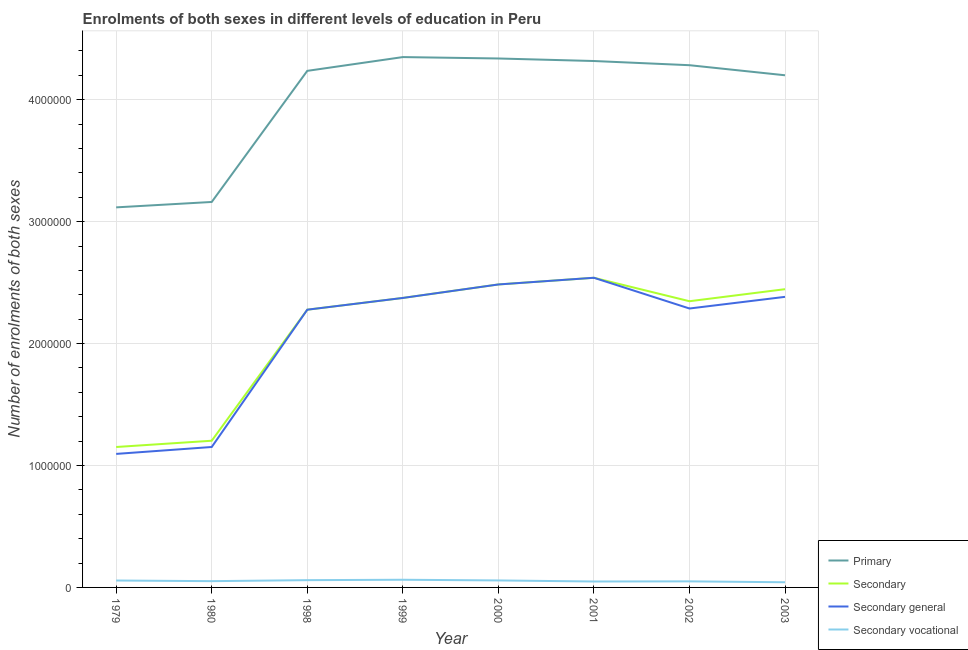How many different coloured lines are there?
Your answer should be compact. 4. Does the line corresponding to number of enrolments in secondary vocational education intersect with the line corresponding to number of enrolments in secondary education?
Your answer should be compact. No. What is the number of enrolments in secondary education in 2001?
Make the answer very short. 2.54e+06. Across all years, what is the maximum number of enrolments in secondary general education?
Provide a short and direct response. 2.54e+06. Across all years, what is the minimum number of enrolments in primary education?
Your response must be concise. 3.12e+06. In which year was the number of enrolments in secondary vocational education minimum?
Your response must be concise. 2003. What is the total number of enrolments in secondary vocational education in the graph?
Keep it short and to the point. 4.29e+05. What is the difference between the number of enrolments in secondary education in 2000 and that in 2002?
Make the answer very short. 1.38e+05. What is the difference between the number of enrolments in secondary vocational education in 2002 and the number of enrolments in secondary general education in 2001?
Offer a very short reply. -2.49e+06. What is the average number of enrolments in primary education per year?
Make the answer very short. 4.00e+06. In the year 2002, what is the difference between the number of enrolments in secondary education and number of enrolments in secondary vocational education?
Offer a very short reply. 2.30e+06. In how many years, is the number of enrolments in secondary general education greater than 4200000?
Provide a succinct answer. 0. What is the ratio of the number of enrolments in secondary general education in 2001 to that in 2002?
Offer a very short reply. 1.11. Is the number of enrolments in secondary general education in 1979 less than that in 1998?
Provide a succinct answer. Yes. What is the difference between the highest and the second highest number of enrolments in secondary education?
Provide a short and direct response. 5.49e+04. What is the difference between the highest and the lowest number of enrolments in secondary vocational education?
Ensure brevity in your answer.  2.05e+04. Does the number of enrolments in secondary education monotonically increase over the years?
Provide a succinct answer. No. Is the number of enrolments in secondary education strictly greater than the number of enrolments in secondary vocational education over the years?
Offer a terse response. Yes. Is the number of enrolments in secondary education strictly less than the number of enrolments in secondary general education over the years?
Make the answer very short. No. How many years are there in the graph?
Your answer should be very brief. 8. Does the graph contain grids?
Give a very brief answer. Yes. What is the title of the graph?
Offer a very short reply. Enrolments of both sexes in different levels of education in Peru. What is the label or title of the X-axis?
Provide a short and direct response. Year. What is the label or title of the Y-axis?
Your response must be concise. Number of enrolments of both sexes. What is the Number of enrolments of both sexes of Primary in 1979?
Provide a succinct answer. 3.12e+06. What is the Number of enrolments of both sexes in Secondary in 1979?
Make the answer very short. 1.15e+06. What is the Number of enrolments of both sexes in Secondary general in 1979?
Your answer should be compact. 1.10e+06. What is the Number of enrolments of both sexes in Secondary vocational in 1979?
Make the answer very short. 5.67e+04. What is the Number of enrolments of both sexes in Primary in 1980?
Give a very brief answer. 3.16e+06. What is the Number of enrolments of both sexes in Secondary in 1980?
Make the answer very short. 1.20e+06. What is the Number of enrolments of both sexes of Secondary general in 1980?
Keep it short and to the point. 1.15e+06. What is the Number of enrolments of both sexes in Secondary vocational in 1980?
Your answer should be very brief. 5.14e+04. What is the Number of enrolments of both sexes in Primary in 1998?
Give a very brief answer. 4.24e+06. What is the Number of enrolments of both sexes in Secondary in 1998?
Offer a very short reply. 2.28e+06. What is the Number of enrolments of both sexes of Secondary general in 1998?
Offer a very short reply. 2.28e+06. What is the Number of enrolments of both sexes of Secondary vocational in 1998?
Provide a succinct answer. 5.97e+04. What is the Number of enrolments of both sexes of Primary in 1999?
Provide a short and direct response. 4.35e+06. What is the Number of enrolments of both sexes in Secondary in 1999?
Offer a terse response. 2.37e+06. What is the Number of enrolments of both sexes in Secondary general in 1999?
Your response must be concise. 2.37e+06. What is the Number of enrolments of both sexes of Secondary vocational in 1999?
Give a very brief answer. 6.29e+04. What is the Number of enrolments of both sexes in Primary in 2000?
Your answer should be very brief. 4.34e+06. What is the Number of enrolments of both sexes of Secondary in 2000?
Make the answer very short. 2.48e+06. What is the Number of enrolments of both sexes of Secondary general in 2000?
Your answer should be compact. 2.48e+06. What is the Number of enrolments of both sexes of Secondary vocational in 2000?
Provide a short and direct response. 5.73e+04. What is the Number of enrolments of both sexes in Primary in 2001?
Provide a short and direct response. 4.32e+06. What is the Number of enrolments of both sexes of Secondary in 2001?
Give a very brief answer. 2.54e+06. What is the Number of enrolments of both sexes in Secondary general in 2001?
Ensure brevity in your answer.  2.54e+06. What is the Number of enrolments of both sexes in Secondary vocational in 2001?
Your response must be concise. 4.86e+04. What is the Number of enrolments of both sexes in Primary in 2002?
Make the answer very short. 4.28e+06. What is the Number of enrolments of both sexes in Secondary in 2002?
Ensure brevity in your answer.  2.35e+06. What is the Number of enrolments of both sexes in Secondary general in 2002?
Make the answer very short. 2.29e+06. What is the Number of enrolments of both sexes of Secondary vocational in 2002?
Your answer should be compact. 4.98e+04. What is the Number of enrolments of both sexes in Primary in 2003?
Provide a succinct answer. 4.20e+06. What is the Number of enrolments of both sexes in Secondary in 2003?
Offer a terse response. 2.45e+06. What is the Number of enrolments of both sexes in Secondary general in 2003?
Your answer should be compact. 2.38e+06. What is the Number of enrolments of both sexes in Secondary vocational in 2003?
Make the answer very short. 4.24e+04. Across all years, what is the maximum Number of enrolments of both sexes of Primary?
Provide a short and direct response. 4.35e+06. Across all years, what is the maximum Number of enrolments of both sexes of Secondary?
Make the answer very short. 2.54e+06. Across all years, what is the maximum Number of enrolments of both sexes in Secondary general?
Provide a short and direct response. 2.54e+06. Across all years, what is the maximum Number of enrolments of both sexes in Secondary vocational?
Your answer should be very brief. 6.29e+04. Across all years, what is the minimum Number of enrolments of both sexes of Primary?
Keep it short and to the point. 3.12e+06. Across all years, what is the minimum Number of enrolments of both sexes in Secondary?
Ensure brevity in your answer.  1.15e+06. Across all years, what is the minimum Number of enrolments of both sexes in Secondary general?
Offer a terse response. 1.10e+06. Across all years, what is the minimum Number of enrolments of both sexes in Secondary vocational?
Give a very brief answer. 4.24e+04. What is the total Number of enrolments of both sexes in Primary in the graph?
Offer a very short reply. 3.20e+07. What is the total Number of enrolments of both sexes of Secondary in the graph?
Offer a very short reply. 1.68e+07. What is the total Number of enrolments of both sexes of Secondary general in the graph?
Offer a very short reply. 1.66e+07. What is the total Number of enrolments of both sexes of Secondary vocational in the graph?
Your answer should be compact. 4.29e+05. What is the difference between the Number of enrolments of both sexes of Primary in 1979 and that in 1980?
Provide a short and direct response. -4.43e+04. What is the difference between the Number of enrolments of both sexes of Secondary in 1979 and that in 1980?
Make the answer very short. -5.14e+04. What is the difference between the Number of enrolments of both sexes in Secondary general in 1979 and that in 1980?
Make the answer very short. -5.67e+04. What is the difference between the Number of enrolments of both sexes of Secondary vocational in 1979 and that in 1980?
Keep it short and to the point. 5325. What is the difference between the Number of enrolments of both sexes in Primary in 1979 and that in 1998?
Keep it short and to the point. -1.12e+06. What is the difference between the Number of enrolments of both sexes of Secondary in 1979 and that in 1998?
Ensure brevity in your answer.  -1.13e+06. What is the difference between the Number of enrolments of both sexes in Secondary general in 1979 and that in 1998?
Your answer should be very brief. -1.18e+06. What is the difference between the Number of enrolments of both sexes of Secondary vocational in 1979 and that in 1998?
Offer a terse response. -2965. What is the difference between the Number of enrolments of both sexes of Primary in 1979 and that in 1999?
Provide a short and direct response. -1.23e+06. What is the difference between the Number of enrolments of both sexes in Secondary in 1979 and that in 1999?
Your answer should be compact. -1.22e+06. What is the difference between the Number of enrolments of both sexes of Secondary general in 1979 and that in 1999?
Give a very brief answer. -1.28e+06. What is the difference between the Number of enrolments of both sexes of Secondary vocational in 1979 and that in 1999?
Give a very brief answer. -6219. What is the difference between the Number of enrolments of both sexes of Primary in 1979 and that in 2000?
Provide a short and direct response. -1.22e+06. What is the difference between the Number of enrolments of both sexes in Secondary in 1979 and that in 2000?
Offer a very short reply. -1.33e+06. What is the difference between the Number of enrolments of both sexes in Secondary general in 1979 and that in 2000?
Your answer should be compact. -1.39e+06. What is the difference between the Number of enrolments of both sexes of Secondary vocational in 1979 and that in 2000?
Provide a succinct answer. -591. What is the difference between the Number of enrolments of both sexes of Primary in 1979 and that in 2001?
Keep it short and to the point. -1.20e+06. What is the difference between the Number of enrolments of both sexes of Secondary in 1979 and that in 2001?
Your answer should be very brief. -1.39e+06. What is the difference between the Number of enrolments of both sexes of Secondary general in 1979 and that in 2001?
Provide a succinct answer. -1.44e+06. What is the difference between the Number of enrolments of both sexes of Secondary vocational in 1979 and that in 2001?
Keep it short and to the point. 8056. What is the difference between the Number of enrolments of both sexes in Primary in 1979 and that in 2002?
Give a very brief answer. -1.17e+06. What is the difference between the Number of enrolments of both sexes of Secondary in 1979 and that in 2002?
Ensure brevity in your answer.  -1.20e+06. What is the difference between the Number of enrolments of both sexes of Secondary general in 1979 and that in 2002?
Offer a terse response. -1.19e+06. What is the difference between the Number of enrolments of both sexes of Secondary vocational in 1979 and that in 2002?
Make the answer very short. 6923. What is the difference between the Number of enrolments of both sexes of Primary in 1979 and that in 2003?
Make the answer very short. -1.08e+06. What is the difference between the Number of enrolments of both sexes in Secondary in 1979 and that in 2003?
Your answer should be compact. -1.29e+06. What is the difference between the Number of enrolments of both sexes of Secondary general in 1979 and that in 2003?
Give a very brief answer. -1.29e+06. What is the difference between the Number of enrolments of both sexes in Secondary vocational in 1979 and that in 2003?
Offer a terse response. 1.43e+04. What is the difference between the Number of enrolments of both sexes in Primary in 1980 and that in 1998?
Ensure brevity in your answer.  -1.08e+06. What is the difference between the Number of enrolments of both sexes in Secondary in 1980 and that in 1998?
Your answer should be compact. -1.07e+06. What is the difference between the Number of enrolments of both sexes in Secondary general in 1980 and that in 1998?
Keep it short and to the point. -1.13e+06. What is the difference between the Number of enrolments of both sexes in Secondary vocational in 1980 and that in 1998?
Your answer should be compact. -8290. What is the difference between the Number of enrolments of both sexes in Primary in 1980 and that in 1999?
Offer a terse response. -1.19e+06. What is the difference between the Number of enrolments of both sexes in Secondary in 1980 and that in 1999?
Offer a very short reply. -1.17e+06. What is the difference between the Number of enrolments of both sexes in Secondary general in 1980 and that in 1999?
Your answer should be compact. -1.22e+06. What is the difference between the Number of enrolments of both sexes in Secondary vocational in 1980 and that in 1999?
Make the answer very short. -1.15e+04. What is the difference between the Number of enrolments of both sexes in Primary in 1980 and that in 2000?
Make the answer very short. -1.18e+06. What is the difference between the Number of enrolments of both sexes in Secondary in 1980 and that in 2000?
Provide a succinct answer. -1.28e+06. What is the difference between the Number of enrolments of both sexes in Secondary general in 1980 and that in 2000?
Keep it short and to the point. -1.33e+06. What is the difference between the Number of enrolments of both sexes of Secondary vocational in 1980 and that in 2000?
Give a very brief answer. -5916. What is the difference between the Number of enrolments of both sexes of Primary in 1980 and that in 2001?
Your response must be concise. -1.16e+06. What is the difference between the Number of enrolments of both sexes in Secondary in 1980 and that in 2001?
Your response must be concise. -1.34e+06. What is the difference between the Number of enrolments of both sexes in Secondary general in 1980 and that in 2001?
Ensure brevity in your answer.  -1.39e+06. What is the difference between the Number of enrolments of both sexes of Secondary vocational in 1980 and that in 2001?
Offer a very short reply. 2731. What is the difference between the Number of enrolments of both sexes of Primary in 1980 and that in 2002?
Make the answer very short. -1.12e+06. What is the difference between the Number of enrolments of both sexes of Secondary in 1980 and that in 2002?
Offer a terse response. -1.14e+06. What is the difference between the Number of enrolments of both sexes of Secondary general in 1980 and that in 2002?
Provide a short and direct response. -1.14e+06. What is the difference between the Number of enrolments of both sexes of Secondary vocational in 1980 and that in 2002?
Your answer should be very brief. 1598. What is the difference between the Number of enrolments of both sexes in Primary in 1980 and that in 2003?
Offer a terse response. -1.04e+06. What is the difference between the Number of enrolments of both sexes of Secondary in 1980 and that in 2003?
Give a very brief answer. -1.24e+06. What is the difference between the Number of enrolments of both sexes in Secondary general in 1980 and that in 2003?
Your answer should be very brief. -1.23e+06. What is the difference between the Number of enrolments of both sexes of Secondary vocational in 1980 and that in 2003?
Your answer should be very brief. 8989. What is the difference between the Number of enrolments of both sexes in Primary in 1998 and that in 1999?
Provide a succinct answer. -1.13e+05. What is the difference between the Number of enrolments of both sexes of Secondary in 1998 and that in 1999?
Your answer should be compact. -9.64e+04. What is the difference between the Number of enrolments of both sexes of Secondary general in 1998 and that in 1999?
Provide a short and direct response. -9.64e+04. What is the difference between the Number of enrolments of both sexes of Secondary vocational in 1998 and that in 1999?
Offer a very short reply. -3254. What is the difference between the Number of enrolments of both sexes of Primary in 1998 and that in 2000?
Provide a succinct answer. -1.01e+05. What is the difference between the Number of enrolments of both sexes in Secondary in 1998 and that in 2000?
Provide a short and direct response. -2.07e+05. What is the difference between the Number of enrolments of both sexes in Secondary general in 1998 and that in 2000?
Your response must be concise. -2.07e+05. What is the difference between the Number of enrolments of both sexes of Secondary vocational in 1998 and that in 2000?
Offer a terse response. 2374. What is the difference between the Number of enrolments of both sexes in Primary in 1998 and that in 2001?
Provide a short and direct response. -8.08e+04. What is the difference between the Number of enrolments of both sexes of Secondary in 1998 and that in 2001?
Your response must be concise. -2.62e+05. What is the difference between the Number of enrolments of both sexes of Secondary general in 1998 and that in 2001?
Keep it short and to the point. -2.62e+05. What is the difference between the Number of enrolments of both sexes of Secondary vocational in 1998 and that in 2001?
Your answer should be very brief. 1.10e+04. What is the difference between the Number of enrolments of both sexes in Primary in 1998 and that in 2002?
Your answer should be compact. -4.65e+04. What is the difference between the Number of enrolments of both sexes in Secondary in 1998 and that in 2002?
Offer a very short reply. -6.94e+04. What is the difference between the Number of enrolments of both sexes in Secondary general in 1998 and that in 2002?
Your answer should be very brief. -9776. What is the difference between the Number of enrolments of both sexes in Secondary vocational in 1998 and that in 2002?
Give a very brief answer. 9888. What is the difference between the Number of enrolments of both sexes in Primary in 1998 and that in 2003?
Your response must be concise. 3.61e+04. What is the difference between the Number of enrolments of both sexes in Secondary in 1998 and that in 2003?
Your answer should be compact. -1.68e+05. What is the difference between the Number of enrolments of both sexes of Secondary general in 1998 and that in 2003?
Your answer should be compact. -1.05e+05. What is the difference between the Number of enrolments of both sexes in Secondary vocational in 1998 and that in 2003?
Your answer should be compact. 1.73e+04. What is the difference between the Number of enrolments of both sexes of Primary in 1999 and that in 2000?
Keep it short and to the point. 1.15e+04. What is the difference between the Number of enrolments of both sexes in Secondary in 1999 and that in 2000?
Give a very brief answer. -1.11e+05. What is the difference between the Number of enrolments of both sexes of Secondary general in 1999 and that in 2000?
Your response must be concise. -1.11e+05. What is the difference between the Number of enrolments of both sexes in Secondary vocational in 1999 and that in 2000?
Keep it short and to the point. 5628. What is the difference between the Number of enrolments of both sexes of Primary in 1999 and that in 2001?
Keep it short and to the point. 3.22e+04. What is the difference between the Number of enrolments of both sexes of Secondary in 1999 and that in 2001?
Provide a short and direct response. -1.66e+05. What is the difference between the Number of enrolments of both sexes in Secondary general in 1999 and that in 2001?
Ensure brevity in your answer.  -1.66e+05. What is the difference between the Number of enrolments of both sexes of Secondary vocational in 1999 and that in 2001?
Offer a terse response. 1.43e+04. What is the difference between the Number of enrolments of both sexes of Primary in 1999 and that in 2002?
Provide a short and direct response. 6.65e+04. What is the difference between the Number of enrolments of both sexes of Secondary in 1999 and that in 2002?
Ensure brevity in your answer.  2.69e+04. What is the difference between the Number of enrolments of both sexes in Secondary general in 1999 and that in 2002?
Offer a very short reply. 8.66e+04. What is the difference between the Number of enrolments of both sexes in Secondary vocational in 1999 and that in 2002?
Provide a short and direct response. 1.31e+04. What is the difference between the Number of enrolments of both sexes of Primary in 1999 and that in 2003?
Ensure brevity in your answer.  1.49e+05. What is the difference between the Number of enrolments of both sexes in Secondary in 1999 and that in 2003?
Your response must be concise. -7.19e+04. What is the difference between the Number of enrolments of both sexes of Secondary general in 1999 and that in 2003?
Offer a terse response. -8951. What is the difference between the Number of enrolments of both sexes in Secondary vocational in 1999 and that in 2003?
Your response must be concise. 2.05e+04. What is the difference between the Number of enrolments of both sexes in Primary in 2000 and that in 2001?
Keep it short and to the point. 2.07e+04. What is the difference between the Number of enrolments of both sexes of Secondary in 2000 and that in 2001?
Ensure brevity in your answer.  -5.49e+04. What is the difference between the Number of enrolments of both sexes of Secondary general in 2000 and that in 2001?
Your answer should be compact. -5.49e+04. What is the difference between the Number of enrolments of both sexes in Secondary vocational in 2000 and that in 2001?
Provide a succinct answer. 8647. What is the difference between the Number of enrolments of both sexes in Primary in 2000 and that in 2002?
Give a very brief answer. 5.50e+04. What is the difference between the Number of enrolments of both sexes in Secondary in 2000 and that in 2002?
Your answer should be compact. 1.38e+05. What is the difference between the Number of enrolments of both sexes of Secondary general in 2000 and that in 2002?
Provide a short and direct response. 1.97e+05. What is the difference between the Number of enrolments of both sexes of Secondary vocational in 2000 and that in 2002?
Offer a very short reply. 7514. What is the difference between the Number of enrolments of both sexes in Primary in 2000 and that in 2003?
Your response must be concise. 1.38e+05. What is the difference between the Number of enrolments of both sexes in Secondary in 2000 and that in 2003?
Provide a succinct answer. 3.87e+04. What is the difference between the Number of enrolments of both sexes in Secondary general in 2000 and that in 2003?
Provide a short and direct response. 1.02e+05. What is the difference between the Number of enrolments of both sexes in Secondary vocational in 2000 and that in 2003?
Your answer should be compact. 1.49e+04. What is the difference between the Number of enrolments of both sexes in Primary in 2001 and that in 2002?
Offer a terse response. 3.43e+04. What is the difference between the Number of enrolments of both sexes in Secondary in 2001 and that in 2002?
Ensure brevity in your answer.  1.92e+05. What is the difference between the Number of enrolments of both sexes of Secondary general in 2001 and that in 2002?
Give a very brief answer. 2.52e+05. What is the difference between the Number of enrolments of both sexes in Secondary vocational in 2001 and that in 2002?
Your answer should be very brief. -1133. What is the difference between the Number of enrolments of both sexes of Primary in 2001 and that in 2003?
Give a very brief answer. 1.17e+05. What is the difference between the Number of enrolments of both sexes in Secondary in 2001 and that in 2003?
Offer a very short reply. 9.36e+04. What is the difference between the Number of enrolments of both sexes of Secondary general in 2001 and that in 2003?
Make the answer very short. 1.57e+05. What is the difference between the Number of enrolments of both sexes of Secondary vocational in 2001 and that in 2003?
Give a very brief answer. 6258. What is the difference between the Number of enrolments of both sexes of Primary in 2002 and that in 2003?
Offer a very short reply. 8.26e+04. What is the difference between the Number of enrolments of both sexes of Secondary in 2002 and that in 2003?
Keep it short and to the point. -9.88e+04. What is the difference between the Number of enrolments of both sexes of Secondary general in 2002 and that in 2003?
Provide a succinct answer. -9.55e+04. What is the difference between the Number of enrolments of both sexes of Secondary vocational in 2002 and that in 2003?
Make the answer very short. 7391. What is the difference between the Number of enrolments of both sexes in Primary in 1979 and the Number of enrolments of both sexes in Secondary in 1980?
Make the answer very short. 1.91e+06. What is the difference between the Number of enrolments of both sexes in Primary in 1979 and the Number of enrolments of both sexes in Secondary general in 1980?
Keep it short and to the point. 1.97e+06. What is the difference between the Number of enrolments of both sexes of Primary in 1979 and the Number of enrolments of both sexes of Secondary vocational in 1980?
Your answer should be compact. 3.07e+06. What is the difference between the Number of enrolments of both sexes of Secondary in 1979 and the Number of enrolments of both sexes of Secondary vocational in 1980?
Provide a succinct answer. 1.10e+06. What is the difference between the Number of enrolments of both sexes of Secondary general in 1979 and the Number of enrolments of both sexes of Secondary vocational in 1980?
Offer a very short reply. 1.04e+06. What is the difference between the Number of enrolments of both sexes in Primary in 1979 and the Number of enrolments of both sexes in Secondary in 1998?
Provide a succinct answer. 8.39e+05. What is the difference between the Number of enrolments of both sexes in Primary in 1979 and the Number of enrolments of both sexes in Secondary general in 1998?
Make the answer very short. 8.39e+05. What is the difference between the Number of enrolments of both sexes in Primary in 1979 and the Number of enrolments of both sexes in Secondary vocational in 1998?
Provide a short and direct response. 3.06e+06. What is the difference between the Number of enrolments of both sexes in Secondary in 1979 and the Number of enrolments of both sexes in Secondary general in 1998?
Provide a succinct answer. -1.13e+06. What is the difference between the Number of enrolments of both sexes in Secondary in 1979 and the Number of enrolments of both sexes in Secondary vocational in 1998?
Offer a terse response. 1.09e+06. What is the difference between the Number of enrolments of both sexes in Secondary general in 1979 and the Number of enrolments of both sexes in Secondary vocational in 1998?
Offer a terse response. 1.04e+06. What is the difference between the Number of enrolments of both sexes in Primary in 1979 and the Number of enrolments of both sexes in Secondary in 1999?
Make the answer very short. 7.43e+05. What is the difference between the Number of enrolments of both sexes in Primary in 1979 and the Number of enrolments of both sexes in Secondary general in 1999?
Offer a terse response. 7.43e+05. What is the difference between the Number of enrolments of both sexes in Primary in 1979 and the Number of enrolments of both sexes in Secondary vocational in 1999?
Provide a succinct answer. 3.05e+06. What is the difference between the Number of enrolments of both sexes of Secondary in 1979 and the Number of enrolments of both sexes of Secondary general in 1999?
Give a very brief answer. -1.22e+06. What is the difference between the Number of enrolments of both sexes of Secondary in 1979 and the Number of enrolments of both sexes of Secondary vocational in 1999?
Keep it short and to the point. 1.09e+06. What is the difference between the Number of enrolments of both sexes of Secondary general in 1979 and the Number of enrolments of both sexes of Secondary vocational in 1999?
Give a very brief answer. 1.03e+06. What is the difference between the Number of enrolments of both sexes of Primary in 1979 and the Number of enrolments of both sexes of Secondary in 2000?
Provide a succinct answer. 6.32e+05. What is the difference between the Number of enrolments of both sexes of Primary in 1979 and the Number of enrolments of both sexes of Secondary general in 2000?
Make the answer very short. 6.32e+05. What is the difference between the Number of enrolments of both sexes of Primary in 1979 and the Number of enrolments of both sexes of Secondary vocational in 2000?
Provide a short and direct response. 3.06e+06. What is the difference between the Number of enrolments of both sexes in Secondary in 1979 and the Number of enrolments of both sexes in Secondary general in 2000?
Your response must be concise. -1.33e+06. What is the difference between the Number of enrolments of both sexes of Secondary in 1979 and the Number of enrolments of both sexes of Secondary vocational in 2000?
Give a very brief answer. 1.09e+06. What is the difference between the Number of enrolments of both sexes of Secondary general in 1979 and the Number of enrolments of both sexes of Secondary vocational in 2000?
Give a very brief answer. 1.04e+06. What is the difference between the Number of enrolments of both sexes in Primary in 1979 and the Number of enrolments of both sexes in Secondary in 2001?
Offer a very short reply. 5.77e+05. What is the difference between the Number of enrolments of both sexes of Primary in 1979 and the Number of enrolments of both sexes of Secondary general in 2001?
Make the answer very short. 5.77e+05. What is the difference between the Number of enrolments of both sexes in Primary in 1979 and the Number of enrolments of both sexes in Secondary vocational in 2001?
Provide a succinct answer. 3.07e+06. What is the difference between the Number of enrolments of both sexes of Secondary in 1979 and the Number of enrolments of both sexes of Secondary general in 2001?
Provide a short and direct response. -1.39e+06. What is the difference between the Number of enrolments of both sexes in Secondary in 1979 and the Number of enrolments of both sexes in Secondary vocational in 2001?
Your response must be concise. 1.10e+06. What is the difference between the Number of enrolments of both sexes in Secondary general in 1979 and the Number of enrolments of both sexes in Secondary vocational in 2001?
Provide a short and direct response. 1.05e+06. What is the difference between the Number of enrolments of both sexes in Primary in 1979 and the Number of enrolments of both sexes in Secondary in 2002?
Offer a very short reply. 7.70e+05. What is the difference between the Number of enrolments of both sexes in Primary in 1979 and the Number of enrolments of both sexes in Secondary general in 2002?
Provide a succinct answer. 8.29e+05. What is the difference between the Number of enrolments of both sexes of Primary in 1979 and the Number of enrolments of both sexes of Secondary vocational in 2002?
Your response must be concise. 3.07e+06. What is the difference between the Number of enrolments of both sexes in Secondary in 1979 and the Number of enrolments of both sexes in Secondary general in 2002?
Provide a short and direct response. -1.14e+06. What is the difference between the Number of enrolments of both sexes in Secondary in 1979 and the Number of enrolments of both sexes in Secondary vocational in 2002?
Provide a short and direct response. 1.10e+06. What is the difference between the Number of enrolments of both sexes in Secondary general in 1979 and the Number of enrolments of both sexes in Secondary vocational in 2002?
Provide a succinct answer. 1.05e+06. What is the difference between the Number of enrolments of both sexes in Primary in 1979 and the Number of enrolments of both sexes in Secondary in 2003?
Provide a succinct answer. 6.71e+05. What is the difference between the Number of enrolments of both sexes in Primary in 1979 and the Number of enrolments of both sexes in Secondary general in 2003?
Offer a terse response. 7.34e+05. What is the difference between the Number of enrolments of both sexes of Primary in 1979 and the Number of enrolments of both sexes of Secondary vocational in 2003?
Provide a short and direct response. 3.07e+06. What is the difference between the Number of enrolments of both sexes in Secondary in 1979 and the Number of enrolments of both sexes in Secondary general in 2003?
Your answer should be compact. -1.23e+06. What is the difference between the Number of enrolments of both sexes of Secondary in 1979 and the Number of enrolments of both sexes of Secondary vocational in 2003?
Give a very brief answer. 1.11e+06. What is the difference between the Number of enrolments of both sexes in Secondary general in 1979 and the Number of enrolments of both sexes in Secondary vocational in 2003?
Your answer should be compact. 1.05e+06. What is the difference between the Number of enrolments of both sexes in Primary in 1980 and the Number of enrolments of both sexes in Secondary in 1998?
Your answer should be compact. 8.84e+05. What is the difference between the Number of enrolments of both sexes in Primary in 1980 and the Number of enrolments of both sexes in Secondary general in 1998?
Offer a terse response. 8.84e+05. What is the difference between the Number of enrolments of both sexes in Primary in 1980 and the Number of enrolments of both sexes in Secondary vocational in 1998?
Offer a very short reply. 3.10e+06. What is the difference between the Number of enrolments of both sexes in Secondary in 1980 and the Number of enrolments of both sexes in Secondary general in 1998?
Provide a succinct answer. -1.07e+06. What is the difference between the Number of enrolments of both sexes in Secondary in 1980 and the Number of enrolments of both sexes in Secondary vocational in 1998?
Keep it short and to the point. 1.14e+06. What is the difference between the Number of enrolments of both sexes of Secondary general in 1980 and the Number of enrolments of both sexes of Secondary vocational in 1998?
Make the answer very short. 1.09e+06. What is the difference between the Number of enrolments of both sexes of Primary in 1980 and the Number of enrolments of both sexes of Secondary in 1999?
Give a very brief answer. 7.87e+05. What is the difference between the Number of enrolments of both sexes in Primary in 1980 and the Number of enrolments of both sexes in Secondary general in 1999?
Give a very brief answer. 7.87e+05. What is the difference between the Number of enrolments of both sexes in Primary in 1980 and the Number of enrolments of both sexes in Secondary vocational in 1999?
Provide a short and direct response. 3.10e+06. What is the difference between the Number of enrolments of both sexes of Secondary in 1980 and the Number of enrolments of both sexes of Secondary general in 1999?
Your response must be concise. -1.17e+06. What is the difference between the Number of enrolments of both sexes of Secondary in 1980 and the Number of enrolments of both sexes of Secondary vocational in 1999?
Offer a very short reply. 1.14e+06. What is the difference between the Number of enrolments of both sexes in Secondary general in 1980 and the Number of enrolments of both sexes in Secondary vocational in 1999?
Provide a succinct answer. 1.09e+06. What is the difference between the Number of enrolments of both sexes in Primary in 1980 and the Number of enrolments of both sexes in Secondary in 2000?
Provide a succinct answer. 6.77e+05. What is the difference between the Number of enrolments of both sexes in Primary in 1980 and the Number of enrolments of both sexes in Secondary general in 2000?
Offer a very short reply. 6.77e+05. What is the difference between the Number of enrolments of both sexes in Primary in 1980 and the Number of enrolments of both sexes in Secondary vocational in 2000?
Provide a succinct answer. 3.10e+06. What is the difference between the Number of enrolments of both sexes of Secondary in 1980 and the Number of enrolments of both sexes of Secondary general in 2000?
Ensure brevity in your answer.  -1.28e+06. What is the difference between the Number of enrolments of both sexes in Secondary in 1980 and the Number of enrolments of both sexes in Secondary vocational in 2000?
Provide a short and direct response. 1.15e+06. What is the difference between the Number of enrolments of both sexes in Secondary general in 1980 and the Number of enrolments of both sexes in Secondary vocational in 2000?
Your response must be concise. 1.09e+06. What is the difference between the Number of enrolments of both sexes of Primary in 1980 and the Number of enrolments of both sexes of Secondary in 2001?
Keep it short and to the point. 6.22e+05. What is the difference between the Number of enrolments of both sexes in Primary in 1980 and the Number of enrolments of both sexes in Secondary general in 2001?
Your answer should be compact. 6.22e+05. What is the difference between the Number of enrolments of both sexes in Primary in 1980 and the Number of enrolments of both sexes in Secondary vocational in 2001?
Ensure brevity in your answer.  3.11e+06. What is the difference between the Number of enrolments of both sexes in Secondary in 1980 and the Number of enrolments of both sexes in Secondary general in 2001?
Your answer should be very brief. -1.34e+06. What is the difference between the Number of enrolments of both sexes in Secondary in 1980 and the Number of enrolments of both sexes in Secondary vocational in 2001?
Provide a succinct answer. 1.15e+06. What is the difference between the Number of enrolments of both sexes in Secondary general in 1980 and the Number of enrolments of both sexes in Secondary vocational in 2001?
Provide a short and direct response. 1.10e+06. What is the difference between the Number of enrolments of both sexes of Primary in 1980 and the Number of enrolments of both sexes of Secondary in 2002?
Provide a short and direct response. 8.14e+05. What is the difference between the Number of enrolments of both sexes of Primary in 1980 and the Number of enrolments of both sexes of Secondary general in 2002?
Keep it short and to the point. 8.74e+05. What is the difference between the Number of enrolments of both sexes in Primary in 1980 and the Number of enrolments of both sexes in Secondary vocational in 2002?
Keep it short and to the point. 3.11e+06. What is the difference between the Number of enrolments of both sexes of Secondary in 1980 and the Number of enrolments of both sexes of Secondary general in 2002?
Your answer should be compact. -1.08e+06. What is the difference between the Number of enrolments of both sexes of Secondary in 1980 and the Number of enrolments of both sexes of Secondary vocational in 2002?
Your response must be concise. 1.15e+06. What is the difference between the Number of enrolments of both sexes of Secondary general in 1980 and the Number of enrolments of both sexes of Secondary vocational in 2002?
Your response must be concise. 1.10e+06. What is the difference between the Number of enrolments of both sexes of Primary in 1980 and the Number of enrolments of both sexes of Secondary in 2003?
Offer a very short reply. 7.15e+05. What is the difference between the Number of enrolments of both sexes of Primary in 1980 and the Number of enrolments of both sexes of Secondary general in 2003?
Your response must be concise. 7.78e+05. What is the difference between the Number of enrolments of both sexes of Primary in 1980 and the Number of enrolments of both sexes of Secondary vocational in 2003?
Offer a very short reply. 3.12e+06. What is the difference between the Number of enrolments of both sexes of Secondary in 1980 and the Number of enrolments of both sexes of Secondary general in 2003?
Offer a very short reply. -1.18e+06. What is the difference between the Number of enrolments of both sexes of Secondary in 1980 and the Number of enrolments of both sexes of Secondary vocational in 2003?
Keep it short and to the point. 1.16e+06. What is the difference between the Number of enrolments of both sexes in Secondary general in 1980 and the Number of enrolments of both sexes in Secondary vocational in 2003?
Your answer should be very brief. 1.11e+06. What is the difference between the Number of enrolments of both sexes in Primary in 1998 and the Number of enrolments of both sexes in Secondary in 1999?
Offer a terse response. 1.86e+06. What is the difference between the Number of enrolments of both sexes of Primary in 1998 and the Number of enrolments of both sexes of Secondary general in 1999?
Ensure brevity in your answer.  1.86e+06. What is the difference between the Number of enrolments of both sexes of Primary in 1998 and the Number of enrolments of both sexes of Secondary vocational in 1999?
Offer a very short reply. 4.17e+06. What is the difference between the Number of enrolments of both sexes in Secondary in 1998 and the Number of enrolments of both sexes in Secondary general in 1999?
Keep it short and to the point. -9.64e+04. What is the difference between the Number of enrolments of both sexes in Secondary in 1998 and the Number of enrolments of both sexes in Secondary vocational in 1999?
Your response must be concise. 2.21e+06. What is the difference between the Number of enrolments of both sexes in Secondary general in 1998 and the Number of enrolments of both sexes in Secondary vocational in 1999?
Ensure brevity in your answer.  2.21e+06. What is the difference between the Number of enrolments of both sexes of Primary in 1998 and the Number of enrolments of both sexes of Secondary in 2000?
Ensure brevity in your answer.  1.75e+06. What is the difference between the Number of enrolments of both sexes of Primary in 1998 and the Number of enrolments of both sexes of Secondary general in 2000?
Your answer should be compact. 1.75e+06. What is the difference between the Number of enrolments of both sexes of Primary in 1998 and the Number of enrolments of both sexes of Secondary vocational in 2000?
Offer a very short reply. 4.18e+06. What is the difference between the Number of enrolments of both sexes in Secondary in 1998 and the Number of enrolments of both sexes in Secondary general in 2000?
Make the answer very short. -2.07e+05. What is the difference between the Number of enrolments of both sexes in Secondary in 1998 and the Number of enrolments of both sexes in Secondary vocational in 2000?
Offer a terse response. 2.22e+06. What is the difference between the Number of enrolments of both sexes in Secondary general in 1998 and the Number of enrolments of both sexes in Secondary vocational in 2000?
Your answer should be compact. 2.22e+06. What is the difference between the Number of enrolments of both sexes in Primary in 1998 and the Number of enrolments of both sexes in Secondary in 2001?
Provide a short and direct response. 1.70e+06. What is the difference between the Number of enrolments of both sexes of Primary in 1998 and the Number of enrolments of both sexes of Secondary general in 2001?
Your response must be concise. 1.70e+06. What is the difference between the Number of enrolments of both sexes of Primary in 1998 and the Number of enrolments of both sexes of Secondary vocational in 2001?
Ensure brevity in your answer.  4.19e+06. What is the difference between the Number of enrolments of both sexes of Secondary in 1998 and the Number of enrolments of both sexes of Secondary general in 2001?
Provide a succinct answer. -2.62e+05. What is the difference between the Number of enrolments of both sexes of Secondary in 1998 and the Number of enrolments of both sexes of Secondary vocational in 2001?
Offer a terse response. 2.23e+06. What is the difference between the Number of enrolments of both sexes in Secondary general in 1998 and the Number of enrolments of both sexes in Secondary vocational in 2001?
Offer a very short reply. 2.23e+06. What is the difference between the Number of enrolments of both sexes in Primary in 1998 and the Number of enrolments of both sexes in Secondary in 2002?
Provide a succinct answer. 1.89e+06. What is the difference between the Number of enrolments of both sexes in Primary in 1998 and the Number of enrolments of both sexes in Secondary general in 2002?
Offer a very short reply. 1.95e+06. What is the difference between the Number of enrolments of both sexes of Primary in 1998 and the Number of enrolments of both sexes of Secondary vocational in 2002?
Provide a short and direct response. 4.19e+06. What is the difference between the Number of enrolments of both sexes in Secondary in 1998 and the Number of enrolments of both sexes in Secondary general in 2002?
Your answer should be compact. -9776. What is the difference between the Number of enrolments of both sexes in Secondary in 1998 and the Number of enrolments of both sexes in Secondary vocational in 2002?
Make the answer very short. 2.23e+06. What is the difference between the Number of enrolments of both sexes in Secondary general in 1998 and the Number of enrolments of both sexes in Secondary vocational in 2002?
Your response must be concise. 2.23e+06. What is the difference between the Number of enrolments of both sexes of Primary in 1998 and the Number of enrolments of both sexes of Secondary in 2003?
Make the answer very short. 1.79e+06. What is the difference between the Number of enrolments of both sexes of Primary in 1998 and the Number of enrolments of both sexes of Secondary general in 2003?
Offer a very short reply. 1.85e+06. What is the difference between the Number of enrolments of both sexes in Primary in 1998 and the Number of enrolments of both sexes in Secondary vocational in 2003?
Provide a short and direct response. 4.19e+06. What is the difference between the Number of enrolments of both sexes of Secondary in 1998 and the Number of enrolments of both sexes of Secondary general in 2003?
Your answer should be very brief. -1.05e+05. What is the difference between the Number of enrolments of both sexes in Secondary in 1998 and the Number of enrolments of both sexes in Secondary vocational in 2003?
Keep it short and to the point. 2.24e+06. What is the difference between the Number of enrolments of both sexes of Secondary general in 1998 and the Number of enrolments of both sexes of Secondary vocational in 2003?
Provide a succinct answer. 2.24e+06. What is the difference between the Number of enrolments of both sexes of Primary in 1999 and the Number of enrolments of both sexes of Secondary in 2000?
Your answer should be compact. 1.86e+06. What is the difference between the Number of enrolments of both sexes of Primary in 1999 and the Number of enrolments of both sexes of Secondary general in 2000?
Offer a terse response. 1.86e+06. What is the difference between the Number of enrolments of both sexes of Primary in 1999 and the Number of enrolments of both sexes of Secondary vocational in 2000?
Your answer should be compact. 4.29e+06. What is the difference between the Number of enrolments of both sexes of Secondary in 1999 and the Number of enrolments of both sexes of Secondary general in 2000?
Your answer should be compact. -1.11e+05. What is the difference between the Number of enrolments of both sexes of Secondary in 1999 and the Number of enrolments of both sexes of Secondary vocational in 2000?
Offer a terse response. 2.32e+06. What is the difference between the Number of enrolments of both sexes of Secondary general in 1999 and the Number of enrolments of both sexes of Secondary vocational in 2000?
Make the answer very short. 2.32e+06. What is the difference between the Number of enrolments of both sexes of Primary in 1999 and the Number of enrolments of both sexes of Secondary in 2001?
Provide a succinct answer. 1.81e+06. What is the difference between the Number of enrolments of both sexes of Primary in 1999 and the Number of enrolments of both sexes of Secondary general in 2001?
Ensure brevity in your answer.  1.81e+06. What is the difference between the Number of enrolments of both sexes in Primary in 1999 and the Number of enrolments of both sexes in Secondary vocational in 2001?
Ensure brevity in your answer.  4.30e+06. What is the difference between the Number of enrolments of both sexes of Secondary in 1999 and the Number of enrolments of both sexes of Secondary general in 2001?
Offer a very short reply. -1.66e+05. What is the difference between the Number of enrolments of both sexes in Secondary in 1999 and the Number of enrolments of both sexes in Secondary vocational in 2001?
Make the answer very short. 2.33e+06. What is the difference between the Number of enrolments of both sexes in Secondary general in 1999 and the Number of enrolments of both sexes in Secondary vocational in 2001?
Your answer should be compact. 2.33e+06. What is the difference between the Number of enrolments of both sexes in Primary in 1999 and the Number of enrolments of both sexes in Secondary in 2002?
Offer a terse response. 2.00e+06. What is the difference between the Number of enrolments of both sexes of Primary in 1999 and the Number of enrolments of both sexes of Secondary general in 2002?
Give a very brief answer. 2.06e+06. What is the difference between the Number of enrolments of both sexes of Primary in 1999 and the Number of enrolments of both sexes of Secondary vocational in 2002?
Ensure brevity in your answer.  4.30e+06. What is the difference between the Number of enrolments of both sexes of Secondary in 1999 and the Number of enrolments of both sexes of Secondary general in 2002?
Offer a terse response. 8.66e+04. What is the difference between the Number of enrolments of both sexes in Secondary in 1999 and the Number of enrolments of both sexes in Secondary vocational in 2002?
Your answer should be compact. 2.32e+06. What is the difference between the Number of enrolments of both sexes of Secondary general in 1999 and the Number of enrolments of both sexes of Secondary vocational in 2002?
Your answer should be very brief. 2.32e+06. What is the difference between the Number of enrolments of both sexes in Primary in 1999 and the Number of enrolments of both sexes in Secondary in 2003?
Give a very brief answer. 1.90e+06. What is the difference between the Number of enrolments of both sexes in Primary in 1999 and the Number of enrolments of both sexes in Secondary general in 2003?
Ensure brevity in your answer.  1.97e+06. What is the difference between the Number of enrolments of both sexes of Primary in 1999 and the Number of enrolments of both sexes of Secondary vocational in 2003?
Offer a very short reply. 4.31e+06. What is the difference between the Number of enrolments of both sexes in Secondary in 1999 and the Number of enrolments of both sexes in Secondary general in 2003?
Your response must be concise. -8951. What is the difference between the Number of enrolments of both sexes in Secondary in 1999 and the Number of enrolments of both sexes in Secondary vocational in 2003?
Keep it short and to the point. 2.33e+06. What is the difference between the Number of enrolments of both sexes in Secondary general in 1999 and the Number of enrolments of both sexes in Secondary vocational in 2003?
Ensure brevity in your answer.  2.33e+06. What is the difference between the Number of enrolments of both sexes in Primary in 2000 and the Number of enrolments of both sexes in Secondary in 2001?
Your response must be concise. 1.80e+06. What is the difference between the Number of enrolments of both sexes of Primary in 2000 and the Number of enrolments of both sexes of Secondary general in 2001?
Provide a succinct answer. 1.80e+06. What is the difference between the Number of enrolments of both sexes in Primary in 2000 and the Number of enrolments of both sexes in Secondary vocational in 2001?
Your answer should be very brief. 4.29e+06. What is the difference between the Number of enrolments of both sexes of Secondary in 2000 and the Number of enrolments of both sexes of Secondary general in 2001?
Provide a succinct answer. -5.49e+04. What is the difference between the Number of enrolments of both sexes of Secondary in 2000 and the Number of enrolments of both sexes of Secondary vocational in 2001?
Your response must be concise. 2.44e+06. What is the difference between the Number of enrolments of both sexes of Secondary general in 2000 and the Number of enrolments of both sexes of Secondary vocational in 2001?
Keep it short and to the point. 2.44e+06. What is the difference between the Number of enrolments of both sexes of Primary in 2000 and the Number of enrolments of both sexes of Secondary in 2002?
Offer a very short reply. 1.99e+06. What is the difference between the Number of enrolments of both sexes in Primary in 2000 and the Number of enrolments of both sexes in Secondary general in 2002?
Ensure brevity in your answer.  2.05e+06. What is the difference between the Number of enrolments of both sexes of Primary in 2000 and the Number of enrolments of both sexes of Secondary vocational in 2002?
Your answer should be very brief. 4.29e+06. What is the difference between the Number of enrolments of both sexes in Secondary in 2000 and the Number of enrolments of both sexes in Secondary general in 2002?
Keep it short and to the point. 1.97e+05. What is the difference between the Number of enrolments of both sexes of Secondary in 2000 and the Number of enrolments of both sexes of Secondary vocational in 2002?
Provide a short and direct response. 2.44e+06. What is the difference between the Number of enrolments of both sexes in Secondary general in 2000 and the Number of enrolments of both sexes in Secondary vocational in 2002?
Your answer should be compact. 2.44e+06. What is the difference between the Number of enrolments of both sexes of Primary in 2000 and the Number of enrolments of both sexes of Secondary in 2003?
Your response must be concise. 1.89e+06. What is the difference between the Number of enrolments of both sexes in Primary in 2000 and the Number of enrolments of both sexes in Secondary general in 2003?
Your answer should be compact. 1.95e+06. What is the difference between the Number of enrolments of both sexes of Primary in 2000 and the Number of enrolments of both sexes of Secondary vocational in 2003?
Ensure brevity in your answer.  4.30e+06. What is the difference between the Number of enrolments of both sexes in Secondary in 2000 and the Number of enrolments of both sexes in Secondary general in 2003?
Give a very brief answer. 1.02e+05. What is the difference between the Number of enrolments of both sexes in Secondary in 2000 and the Number of enrolments of both sexes in Secondary vocational in 2003?
Give a very brief answer. 2.44e+06. What is the difference between the Number of enrolments of both sexes of Secondary general in 2000 and the Number of enrolments of both sexes of Secondary vocational in 2003?
Your answer should be very brief. 2.44e+06. What is the difference between the Number of enrolments of both sexes of Primary in 2001 and the Number of enrolments of both sexes of Secondary in 2002?
Provide a short and direct response. 1.97e+06. What is the difference between the Number of enrolments of both sexes of Primary in 2001 and the Number of enrolments of both sexes of Secondary general in 2002?
Your answer should be very brief. 2.03e+06. What is the difference between the Number of enrolments of both sexes of Primary in 2001 and the Number of enrolments of both sexes of Secondary vocational in 2002?
Your answer should be compact. 4.27e+06. What is the difference between the Number of enrolments of both sexes of Secondary in 2001 and the Number of enrolments of both sexes of Secondary general in 2002?
Provide a succinct answer. 2.52e+05. What is the difference between the Number of enrolments of both sexes in Secondary in 2001 and the Number of enrolments of both sexes in Secondary vocational in 2002?
Your answer should be very brief. 2.49e+06. What is the difference between the Number of enrolments of both sexes in Secondary general in 2001 and the Number of enrolments of both sexes in Secondary vocational in 2002?
Give a very brief answer. 2.49e+06. What is the difference between the Number of enrolments of both sexes in Primary in 2001 and the Number of enrolments of both sexes in Secondary in 2003?
Provide a succinct answer. 1.87e+06. What is the difference between the Number of enrolments of both sexes in Primary in 2001 and the Number of enrolments of both sexes in Secondary general in 2003?
Your answer should be compact. 1.93e+06. What is the difference between the Number of enrolments of both sexes of Primary in 2001 and the Number of enrolments of both sexes of Secondary vocational in 2003?
Keep it short and to the point. 4.27e+06. What is the difference between the Number of enrolments of both sexes in Secondary in 2001 and the Number of enrolments of both sexes in Secondary general in 2003?
Your answer should be very brief. 1.57e+05. What is the difference between the Number of enrolments of both sexes in Secondary in 2001 and the Number of enrolments of both sexes in Secondary vocational in 2003?
Offer a very short reply. 2.50e+06. What is the difference between the Number of enrolments of both sexes in Secondary general in 2001 and the Number of enrolments of both sexes in Secondary vocational in 2003?
Provide a succinct answer. 2.50e+06. What is the difference between the Number of enrolments of both sexes of Primary in 2002 and the Number of enrolments of both sexes of Secondary in 2003?
Keep it short and to the point. 1.84e+06. What is the difference between the Number of enrolments of both sexes of Primary in 2002 and the Number of enrolments of both sexes of Secondary general in 2003?
Provide a short and direct response. 1.90e+06. What is the difference between the Number of enrolments of both sexes in Primary in 2002 and the Number of enrolments of both sexes in Secondary vocational in 2003?
Keep it short and to the point. 4.24e+06. What is the difference between the Number of enrolments of both sexes in Secondary in 2002 and the Number of enrolments of both sexes in Secondary general in 2003?
Offer a terse response. -3.59e+04. What is the difference between the Number of enrolments of both sexes of Secondary in 2002 and the Number of enrolments of both sexes of Secondary vocational in 2003?
Give a very brief answer. 2.30e+06. What is the difference between the Number of enrolments of both sexes in Secondary general in 2002 and the Number of enrolments of both sexes in Secondary vocational in 2003?
Your answer should be compact. 2.25e+06. What is the average Number of enrolments of both sexes in Primary per year?
Give a very brief answer. 4.00e+06. What is the average Number of enrolments of both sexes of Secondary per year?
Provide a short and direct response. 2.10e+06. What is the average Number of enrolments of both sexes of Secondary general per year?
Keep it short and to the point. 2.07e+06. What is the average Number of enrolments of both sexes of Secondary vocational per year?
Offer a very short reply. 5.36e+04. In the year 1979, what is the difference between the Number of enrolments of both sexes of Primary and Number of enrolments of both sexes of Secondary?
Give a very brief answer. 1.97e+06. In the year 1979, what is the difference between the Number of enrolments of both sexes in Primary and Number of enrolments of both sexes in Secondary general?
Provide a short and direct response. 2.02e+06. In the year 1979, what is the difference between the Number of enrolments of both sexes in Primary and Number of enrolments of both sexes in Secondary vocational?
Ensure brevity in your answer.  3.06e+06. In the year 1979, what is the difference between the Number of enrolments of both sexes in Secondary and Number of enrolments of both sexes in Secondary general?
Offer a terse response. 5.67e+04. In the year 1979, what is the difference between the Number of enrolments of both sexes in Secondary and Number of enrolments of both sexes in Secondary vocational?
Make the answer very short. 1.10e+06. In the year 1979, what is the difference between the Number of enrolments of both sexes of Secondary general and Number of enrolments of both sexes of Secondary vocational?
Make the answer very short. 1.04e+06. In the year 1980, what is the difference between the Number of enrolments of both sexes in Primary and Number of enrolments of both sexes in Secondary?
Provide a succinct answer. 1.96e+06. In the year 1980, what is the difference between the Number of enrolments of both sexes in Primary and Number of enrolments of both sexes in Secondary general?
Provide a succinct answer. 2.01e+06. In the year 1980, what is the difference between the Number of enrolments of both sexes of Primary and Number of enrolments of both sexes of Secondary vocational?
Keep it short and to the point. 3.11e+06. In the year 1980, what is the difference between the Number of enrolments of both sexes of Secondary and Number of enrolments of both sexes of Secondary general?
Make the answer very short. 5.14e+04. In the year 1980, what is the difference between the Number of enrolments of both sexes in Secondary and Number of enrolments of both sexes in Secondary vocational?
Your answer should be compact. 1.15e+06. In the year 1980, what is the difference between the Number of enrolments of both sexes of Secondary general and Number of enrolments of both sexes of Secondary vocational?
Offer a very short reply. 1.10e+06. In the year 1998, what is the difference between the Number of enrolments of both sexes in Primary and Number of enrolments of both sexes in Secondary?
Provide a short and direct response. 1.96e+06. In the year 1998, what is the difference between the Number of enrolments of both sexes in Primary and Number of enrolments of both sexes in Secondary general?
Offer a very short reply. 1.96e+06. In the year 1998, what is the difference between the Number of enrolments of both sexes in Primary and Number of enrolments of both sexes in Secondary vocational?
Your response must be concise. 4.18e+06. In the year 1998, what is the difference between the Number of enrolments of both sexes of Secondary and Number of enrolments of both sexes of Secondary general?
Your answer should be very brief. 0. In the year 1998, what is the difference between the Number of enrolments of both sexes of Secondary and Number of enrolments of both sexes of Secondary vocational?
Keep it short and to the point. 2.22e+06. In the year 1998, what is the difference between the Number of enrolments of both sexes of Secondary general and Number of enrolments of both sexes of Secondary vocational?
Offer a terse response. 2.22e+06. In the year 1999, what is the difference between the Number of enrolments of both sexes of Primary and Number of enrolments of both sexes of Secondary?
Your answer should be compact. 1.98e+06. In the year 1999, what is the difference between the Number of enrolments of both sexes in Primary and Number of enrolments of both sexes in Secondary general?
Your answer should be compact. 1.98e+06. In the year 1999, what is the difference between the Number of enrolments of both sexes in Primary and Number of enrolments of both sexes in Secondary vocational?
Ensure brevity in your answer.  4.29e+06. In the year 1999, what is the difference between the Number of enrolments of both sexes of Secondary and Number of enrolments of both sexes of Secondary general?
Make the answer very short. 0. In the year 1999, what is the difference between the Number of enrolments of both sexes in Secondary and Number of enrolments of both sexes in Secondary vocational?
Offer a very short reply. 2.31e+06. In the year 1999, what is the difference between the Number of enrolments of both sexes in Secondary general and Number of enrolments of both sexes in Secondary vocational?
Your answer should be compact. 2.31e+06. In the year 2000, what is the difference between the Number of enrolments of both sexes of Primary and Number of enrolments of both sexes of Secondary?
Offer a terse response. 1.85e+06. In the year 2000, what is the difference between the Number of enrolments of both sexes in Primary and Number of enrolments of both sexes in Secondary general?
Your answer should be compact. 1.85e+06. In the year 2000, what is the difference between the Number of enrolments of both sexes of Primary and Number of enrolments of both sexes of Secondary vocational?
Provide a succinct answer. 4.28e+06. In the year 2000, what is the difference between the Number of enrolments of both sexes in Secondary and Number of enrolments of both sexes in Secondary vocational?
Offer a terse response. 2.43e+06. In the year 2000, what is the difference between the Number of enrolments of both sexes of Secondary general and Number of enrolments of both sexes of Secondary vocational?
Ensure brevity in your answer.  2.43e+06. In the year 2001, what is the difference between the Number of enrolments of both sexes of Primary and Number of enrolments of both sexes of Secondary?
Offer a very short reply. 1.78e+06. In the year 2001, what is the difference between the Number of enrolments of both sexes of Primary and Number of enrolments of both sexes of Secondary general?
Your answer should be very brief. 1.78e+06. In the year 2001, what is the difference between the Number of enrolments of both sexes of Primary and Number of enrolments of both sexes of Secondary vocational?
Offer a terse response. 4.27e+06. In the year 2001, what is the difference between the Number of enrolments of both sexes in Secondary and Number of enrolments of both sexes in Secondary vocational?
Your answer should be very brief. 2.49e+06. In the year 2001, what is the difference between the Number of enrolments of both sexes in Secondary general and Number of enrolments of both sexes in Secondary vocational?
Your answer should be compact. 2.49e+06. In the year 2002, what is the difference between the Number of enrolments of both sexes in Primary and Number of enrolments of both sexes in Secondary?
Your answer should be compact. 1.94e+06. In the year 2002, what is the difference between the Number of enrolments of both sexes in Primary and Number of enrolments of both sexes in Secondary general?
Keep it short and to the point. 2.00e+06. In the year 2002, what is the difference between the Number of enrolments of both sexes of Primary and Number of enrolments of both sexes of Secondary vocational?
Your answer should be very brief. 4.23e+06. In the year 2002, what is the difference between the Number of enrolments of both sexes of Secondary and Number of enrolments of both sexes of Secondary general?
Make the answer very short. 5.97e+04. In the year 2002, what is the difference between the Number of enrolments of both sexes of Secondary and Number of enrolments of both sexes of Secondary vocational?
Provide a succinct answer. 2.30e+06. In the year 2002, what is the difference between the Number of enrolments of both sexes in Secondary general and Number of enrolments of both sexes in Secondary vocational?
Offer a terse response. 2.24e+06. In the year 2003, what is the difference between the Number of enrolments of both sexes of Primary and Number of enrolments of both sexes of Secondary?
Ensure brevity in your answer.  1.75e+06. In the year 2003, what is the difference between the Number of enrolments of both sexes in Primary and Number of enrolments of both sexes in Secondary general?
Provide a succinct answer. 1.82e+06. In the year 2003, what is the difference between the Number of enrolments of both sexes in Primary and Number of enrolments of both sexes in Secondary vocational?
Offer a very short reply. 4.16e+06. In the year 2003, what is the difference between the Number of enrolments of both sexes in Secondary and Number of enrolments of both sexes in Secondary general?
Give a very brief answer. 6.29e+04. In the year 2003, what is the difference between the Number of enrolments of both sexes in Secondary and Number of enrolments of both sexes in Secondary vocational?
Offer a very short reply. 2.40e+06. In the year 2003, what is the difference between the Number of enrolments of both sexes in Secondary general and Number of enrolments of both sexes in Secondary vocational?
Keep it short and to the point. 2.34e+06. What is the ratio of the Number of enrolments of both sexes in Secondary in 1979 to that in 1980?
Your answer should be very brief. 0.96. What is the ratio of the Number of enrolments of both sexes in Secondary general in 1979 to that in 1980?
Make the answer very short. 0.95. What is the ratio of the Number of enrolments of both sexes of Secondary vocational in 1979 to that in 1980?
Offer a terse response. 1.1. What is the ratio of the Number of enrolments of both sexes in Primary in 1979 to that in 1998?
Provide a short and direct response. 0.74. What is the ratio of the Number of enrolments of both sexes of Secondary in 1979 to that in 1998?
Give a very brief answer. 0.51. What is the ratio of the Number of enrolments of both sexes in Secondary general in 1979 to that in 1998?
Your answer should be compact. 0.48. What is the ratio of the Number of enrolments of both sexes of Secondary vocational in 1979 to that in 1998?
Make the answer very short. 0.95. What is the ratio of the Number of enrolments of both sexes in Primary in 1979 to that in 1999?
Your answer should be compact. 0.72. What is the ratio of the Number of enrolments of both sexes of Secondary in 1979 to that in 1999?
Offer a terse response. 0.49. What is the ratio of the Number of enrolments of both sexes of Secondary general in 1979 to that in 1999?
Your answer should be very brief. 0.46. What is the ratio of the Number of enrolments of both sexes of Secondary vocational in 1979 to that in 1999?
Provide a succinct answer. 0.9. What is the ratio of the Number of enrolments of both sexes in Primary in 1979 to that in 2000?
Your answer should be very brief. 0.72. What is the ratio of the Number of enrolments of both sexes in Secondary in 1979 to that in 2000?
Ensure brevity in your answer.  0.46. What is the ratio of the Number of enrolments of both sexes in Secondary general in 1979 to that in 2000?
Make the answer very short. 0.44. What is the ratio of the Number of enrolments of both sexes in Secondary vocational in 1979 to that in 2000?
Offer a terse response. 0.99. What is the ratio of the Number of enrolments of both sexes in Primary in 1979 to that in 2001?
Make the answer very short. 0.72. What is the ratio of the Number of enrolments of both sexes in Secondary in 1979 to that in 2001?
Your answer should be very brief. 0.45. What is the ratio of the Number of enrolments of both sexes of Secondary general in 1979 to that in 2001?
Offer a very short reply. 0.43. What is the ratio of the Number of enrolments of both sexes of Secondary vocational in 1979 to that in 2001?
Make the answer very short. 1.17. What is the ratio of the Number of enrolments of both sexes of Primary in 1979 to that in 2002?
Offer a terse response. 0.73. What is the ratio of the Number of enrolments of both sexes of Secondary in 1979 to that in 2002?
Your response must be concise. 0.49. What is the ratio of the Number of enrolments of both sexes of Secondary general in 1979 to that in 2002?
Your answer should be very brief. 0.48. What is the ratio of the Number of enrolments of both sexes in Secondary vocational in 1979 to that in 2002?
Your response must be concise. 1.14. What is the ratio of the Number of enrolments of both sexes in Primary in 1979 to that in 2003?
Offer a very short reply. 0.74. What is the ratio of the Number of enrolments of both sexes of Secondary in 1979 to that in 2003?
Your answer should be compact. 0.47. What is the ratio of the Number of enrolments of both sexes of Secondary general in 1979 to that in 2003?
Provide a short and direct response. 0.46. What is the ratio of the Number of enrolments of both sexes in Secondary vocational in 1979 to that in 2003?
Make the answer very short. 1.34. What is the ratio of the Number of enrolments of both sexes in Primary in 1980 to that in 1998?
Make the answer very short. 0.75. What is the ratio of the Number of enrolments of both sexes in Secondary in 1980 to that in 1998?
Ensure brevity in your answer.  0.53. What is the ratio of the Number of enrolments of both sexes in Secondary general in 1980 to that in 1998?
Offer a very short reply. 0.51. What is the ratio of the Number of enrolments of both sexes in Secondary vocational in 1980 to that in 1998?
Ensure brevity in your answer.  0.86. What is the ratio of the Number of enrolments of both sexes of Primary in 1980 to that in 1999?
Offer a terse response. 0.73. What is the ratio of the Number of enrolments of both sexes of Secondary in 1980 to that in 1999?
Your answer should be very brief. 0.51. What is the ratio of the Number of enrolments of both sexes in Secondary general in 1980 to that in 1999?
Offer a very short reply. 0.49. What is the ratio of the Number of enrolments of both sexes of Secondary vocational in 1980 to that in 1999?
Provide a short and direct response. 0.82. What is the ratio of the Number of enrolments of both sexes in Primary in 1980 to that in 2000?
Offer a terse response. 0.73. What is the ratio of the Number of enrolments of both sexes in Secondary in 1980 to that in 2000?
Provide a short and direct response. 0.48. What is the ratio of the Number of enrolments of both sexes in Secondary general in 1980 to that in 2000?
Your response must be concise. 0.46. What is the ratio of the Number of enrolments of both sexes of Secondary vocational in 1980 to that in 2000?
Offer a very short reply. 0.9. What is the ratio of the Number of enrolments of both sexes of Primary in 1980 to that in 2001?
Your response must be concise. 0.73. What is the ratio of the Number of enrolments of both sexes in Secondary in 1980 to that in 2001?
Give a very brief answer. 0.47. What is the ratio of the Number of enrolments of both sexes of Secondary general in 1980 to that in 2001?
Your response must be concise. 0.45. What is the ratio of the Number of enrolments of both sexes of Secondary vocational in 1980 to that in 2001?
Your response must be concise. 1.06. What is the ratio of the Number of enrolments of both sexes of Primary in 1980 to that in 2002?
Offer a terse response. 0.74. What is the ratio of the Number of enrolments of both sexes of Secondary in 1980 to that in 2002?
Provide a succinct answer. 0.51. What is the ratio of the Number of enrolments of both sexes of Secondary general in 1980 to that in 2002?
Give a very brief answer. 0.5. What is the ratio of the Number of enrolments of both sexes of Secondary vocational in 1980 to that in 2002?
Ensure brevity in your answer.  1.03. What is the ratio of the Number of enrolments of both sexes of Primary in 1980 to that in 2003?
Your response must be concise. 0.75. What is the ratio of the Number of enrolments of both sexes of Secondary in 1980 to that in 2003?
Your response must be concise. 0.49. What is the ratio of the Number of enrolments of both sexes in Secondary general in 1980 to that in 2003?
Offer a very short reply. 0.48. What is the ratio of the Number of enrolments of both sexes of Secondary vocational in 1980 to that in 2003?
Your answer should be compact. 1.21. What is the ratio of the Number of enrolments of both sexes of Primary in 1998 to that in 1999?
Give a very brief answer. 0.97. What is the ratio of the Number of enrolments of both sexes of Secondary in 1998 to that in 1999?
Your answer should be compact. 0.96. What is the ratio of the Number of enrolments of both sexes of Secondary general in 1998 to that in 1999?
Keep it short and to the point. 0.96. What is the ratio of the Number of enrolments of both sexes of Secondary vocational in 1998 to that in 1999?
Offer a terse response. 0.95. What is the ratio of the Number of enrolments of both sexes in Primary in 1998 to that in 2000?
Your answer should be very brief. 0.98. What is the ratio of the Number of enrolments of both sexes of Secondary general in 1998 to that in 2000?
Your answer should be very brief. 0.92. What is the ratio of the Number of enrolments of both sexes of Secondary vocational in 1998 to that in 2000?
Offer a very short reply. 1.04. What is the ratio of the Number of enrolments of both sexes in Primary in 1998 to that in 2001?
Provide a succinct answer. 0.98. What is the ratio of the Number of enrolments of both sexes in Secondary in 1998 to that in 2001?
Provide a short and direct response. 0.9. What is the ratio of the Number of enrolments of both sexes of Secondary general in 1998 to that in 2001?
Provide a short and direct response. 0.9. What is the ratio of the Number of enrolments of both sexes in Secondary vocational in 1998 to that in 2001?
Keep it short and to the point. 1.23. What is the ratio of the Number of enrolments of both sexes of Primary in 1998 to that in 2002?
Give a very brief answer. 0.99. What is the ratio of the Number of enrolments of both sexes of Secondary in 1998 to that in 2002?
Make the answer very short. 0.97. What is the ratio of the Number of enrolments of both sexes in Secondary general in 1998 to that in 2002?
Provide a succinct answer. 1. What is the ratio of the Number of enrolments of both sexes of Secondary vocational in 1998 to that in 2002?
Make the answer very short. 1.2. What is the ratio of the Number of enrolments of both sexes of Primary in 1998 to that in 2003?
Keep it short and to the point. 1.01. What is the ratio of the Number of enrolments of both sexes in Secondary in 1998 to that in 2003?
Offer a terse response. 0.93. What is the ratio of the Number of enrolments of both sexes of Secondary general in 1998 to that in 2003?
Provide a short and direct response. 0.96. What is the ratio of the Number of enrolments of both sexes in Secondary vocational in 1998 to that in 2003?
Give a very brief answer. 1.41. What is the ratio of the Number of enrolments of both sexes of Secondary in 1999 to that in 2000?
Your response must be concise. 0.96. What is the ratio of the Number of enrolments of both sexes in Secondary general in 1999 to that in 2000?
Offer a terse response. 0.96. What is the ratio of the Number of enrolments of both sexes of Secondary vocational in 1999 to that in 2000?
Provide a short and direct response. 1.1. What is the ratio of the Number of enrolments of both sexes in Primary in 1999 to that in 2001?
Give a very brief answer. 1.01. What is the ratio of the Number of enrolments of both sexes of Secondary in 1999 to that in 2001?
Ensure brevity in your answer.  0.93. What is the ratio of the Number of enrolments of both sexes in Secondary general in 1999 to that in 2001?
Offer a very short reply. 0.93. What is the ratio of the Number of enrolments of both sexes of Secondary vocational in 1999 to that in 2001?
Make the answer very short. 1.29. What is the ratio of the Number of enrolments of both sexes of Primary in 1999 to that in 2002?
Your answer should be very brief. 1.02. What is the ratio of the Number of enrolments of both sexes of Secondary in 1999 to that in 2002?
Your answer should be compact. 1.01. What is the ratio of the Number of enrolments of both sexes of Secondary general in 1999 to that in 2002?
Provide a succinct answer. 1.04. What is the ratio of the Number of enrolments of both sexes in Secondary vocational in 1999 to that in 2002?
Keep it short and to the point. 1.26. What is the ratio of the Number of enrolments of both sexes of Primary in 1999 to that in 2003?
Offer a terse response. 1.04. What is the ratio of the Number of enrolments of both sexes in Secondary in 1999 to that in 2003?
Your answer should be very brief. 0.97. What is the ratio of the Number of enrolments of both sexes in Secondary vocational in 1999 to that in 2003?
Your answer should be compact. 1.48. What is the ratio of the Number of enrolments of both sexes of Secondary in 2000 to that in 2001?
Your response must be concise. 0.98. What is the ratio of the Number of enrolments of both sexes in Secondary general in 2000 to that in 2001?
Make the answer very short. 0.98. What is the ratio of the Number of enrolments of both sexes in Secondary vocational in 2000 to that in 2001?
Make the answer very short. 1.18. What is the ratio of the Number of enrolments of both sexes of Primary in 2000 to that in 2002?
Offer a very short reply. 1.01. What is the ratio of the Number of enrolments of both sexes of Secondary in 2000 to that in 2002?
Make the answer very short. 1.06. What is the ratio of the Number of enrolments of both sexes of Secondary general in 2000 to that in 2002?
Provide a succinct answer. 1.09. What is the ratio of the Number of enrolments of both sexes of Secondary vocational in 2000 to that in 2002?
Ensure brevity in your answer.  1.15. What is the ratio of the Number of enrolments of both sexes of Primary in 2000 to that in 2003?
Your answer should be very brief. 1.03. What is the ratio of the Number of enrolments of both sexes of Secondary in 2000 to that in 2003?
Offer a terse response. 1.02. What is the ratio of the Number of enrolments of both sexes of Secondary general in 2000 to that in 2003?
Make the answer very short. 1.04. What is the ratio of the Number of enrolments of both sexes in Secondary vocational in 2000 to that in 2003?
Offer a very short reply. 1.35. What is the ratio of the Number of enrolments of both sexes in Secondary in 2001 to that in 2002?
Provide a succinct answer. 1.08. What is the ratio of the Number of enrolments of both sexes in Secondary general in 2001 to that in 2002?
Give a very brief answer. 1.11. What is the ratio of the Number of enrolments of both sexes of Secondary vocational in 2001 to that in 2002?
Your answer should be compact. 0.98. What is the ratio of the Number of enrolments of both sexes in Primary in 2001 to that in 2003?
Offer a very short reply. 1.03. What is the ratio of the Number of enrolments of both sexes of Secondary in 2001 to that in 2003?
Your answer should be compact. 1.04. What is the ratio of the Number of enrolments of both sexes of Secondary general in 2001 to that in 2003?
Provide a short and direct response. 1.07. What is the ratio of the Number of enrolments of both sexes in Secondary vocational in 2001 to that in 2003?
Keep it short and to the point. 1.15. What is the ratio of the Number of enrolments of both sexes in Primary in 2002 to that in 2003?
Ensure brevity in your answer.  1.02. What is the ratio of the Number of enrolments of both sexes in Secondary in 2002 to that in 2003?
Offer a very short reply. 0.96. What is the ratio of the Number of enrolments of both sexes in Secondary general in 2002 to that in 2003?
Offer a very short reply. 0.96. What is the ratio of the Number of enrolments of both sexes in Secondary vocational in 2002 to that in 2003?
Provide a succinct answer. 1.17. What is the difference between the highest and the second highest Number of enrolments of both sexes in Primary?
Provide a short and direct response. 1.15e+04. What is the difference between the highest and the second highest Number of enrolments of both sexes in Secondary?
Make the answer very short. 5.49e+04. What is the difference between the highest and the second highest Number of enrolments of both sexes in Secondary general?
Ensure brevity in your answer.  5.49e+04. What is the difference between the highest and the second highest Number of enrolments of both sexes of Secondary vocational?
Keep it short and to the point. 3254. What is the difference between the highest and the lowest Number of enrolments of both sexes of Primary?
Keep it short and to the point. 1.23e+06. What is the difference between the highest and the lowest Number of enrolments of both sexes of Secondary?
Give a very brief answer. 1.39e+06. What is the difference between the highest and the lowest Number of enrolments of both sexes in Secondary general?
Make the answer very short. 1.44e+06. What is the difference between the highest and the lowest Number of enrolments of both sexes of Secondary vocational?
Your response must be concise. 2.05e+04. 